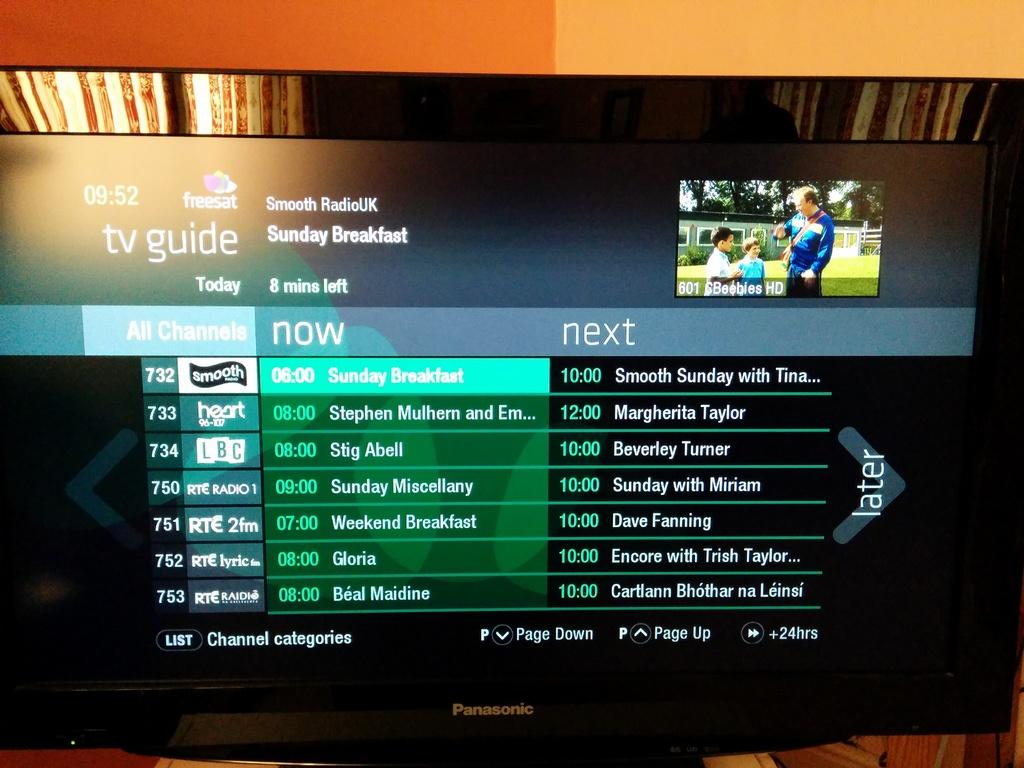<image>
Offer a succinct explanation of the picture presented. A Panasonic television's guide screen shows what is on now and what is next. 